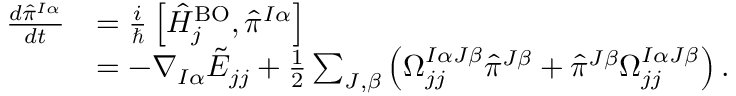<formula> <loc_0><loc_0><loc_500><loc_500>\begin{array} { r l } { \frac { d { \hat { \pi } } ^ { I \alpha } } { d t } } & { = \frac { i } } \left [ \hat { H } _ { j } ^ { B O } , { \hat { \pi } ^ { I \alpha } } \right ] } \\ & { = - \nabla _ { I \alpha } \tilde { E } _ { j j } + \frac { 1 } { 2 } \sum _ { J , \beta } \left ( \Omega _ { j j } ^ { I \alpha J \beta } { \hat { \pi } } ^ { J \beta } + { \hat { \pi } } ^ { J \beta } \Omega _ { j j } ^ { I \alpha J \beta } \right ) . } \end{array}</formula> 